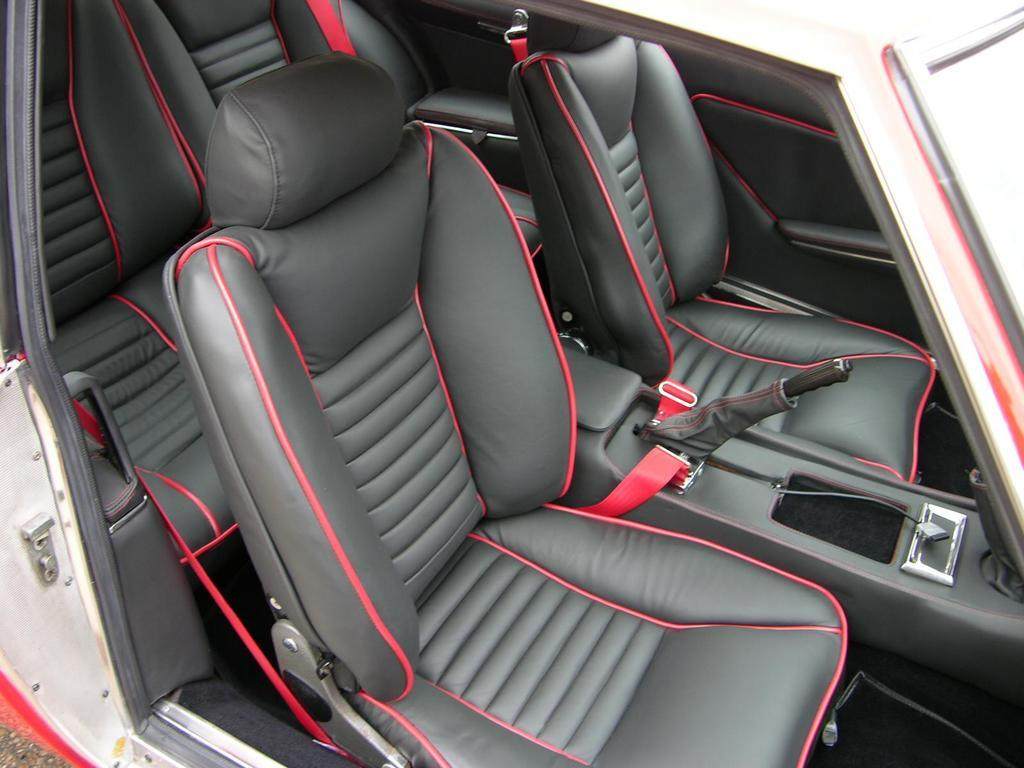What type of setting is depicted in the image? The image is an inside view of a car. What color are the seats in the car? The seats in the car are black. What color are the seat belts in the car? The seat belts in the car are red. What safety feature is present in the car? There is a hand break in the car. How many rabbits can be seen sitting on the seats in the image? There are no rabbits present in the image; it is an inside view of a car with black seats and red seat belts. 